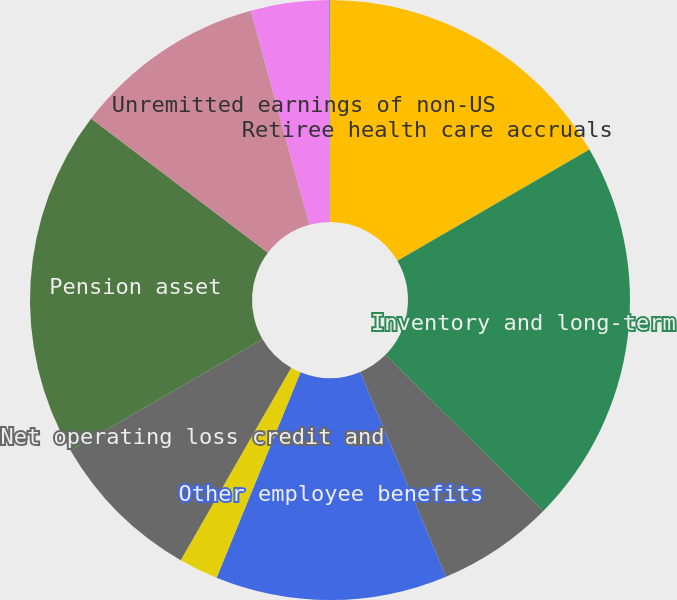Convert chart. <chart><loc_0><loc_0><loc_500><loc_500><pie_chart><fcel>Retiree health care accruals<fcel>Inventory and long-term<fcel>Partnerships and joint<fcel>Other employee benefits<fcel>In-process research and<fcel>Net operating loss credit and<fcel>Pension asset<fcel>Customer and commercial<fcel>Unremitted earnings of non-US<fcel>Other net unrealized losses<nl><fcel>16.63%<fcel>20.78%<fcel>6.27%<fcel>12.49%<fcel>2.12%<fcel>8.34%<fcel>18.71%<fcel>10.41%<fcel>4.2%<fcel>0.05%<nl></chart> 